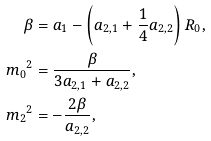Convert formula to latex. <formula><loc_0><loc_0><loc_500><loc_500>\beta & = a _ { 1 } - \left ( a _ { 2 , 1 } + \frac { 1 } { 4 } a _ { 2 , 2 } \right ) R _ { 0 } , \\ { m _ { 0 } } ^ { 2 } & = \frac { \beta } { 3 a _ { 2 , 1 } + a _ { 2 , 2 } } , \\ { m _ { 2 } } ^ { 2 } & = - \frac { 2 \beta } { a _ { 2 , 2 } } ,</formula> 